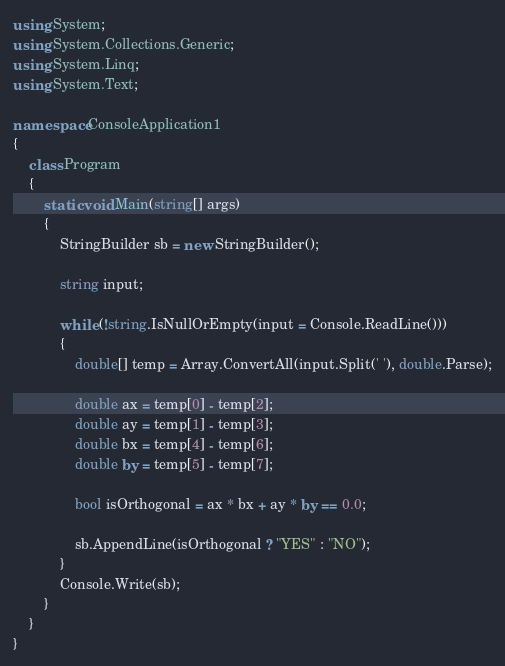Convert code to text. <code><loc_0><loc_0><loc_500><loc_500><_C#_>using System;
using System.Collections.Generic;
using System.Linq;
using System.Text;

namespace ConsoleApplication1
{
    class Program
    {
        static void Main(string[] args)
        {
            StringBuilder sb = new StringBuilder();

            string input;

            while (!string.IsNullOrEmpty(input = Console.ReadLine()))
            {
                double[] temp = Array.ConvertAll(input.Split(' '), double.Parse);

                double ax = temp[0] - temp[2];
                double ay = temp[1] - temp[3];
                double bx = temp[4] - temp[6];
                double by = temp[5] - temp[7];

                bool isOrthogonal = ax * bx + ay * by == 0.0;

                sb.AppendLine(isOrthogonal ? "YES" : "NO");
            }
            Console.Write(sb);
        }
    }
}</code> 